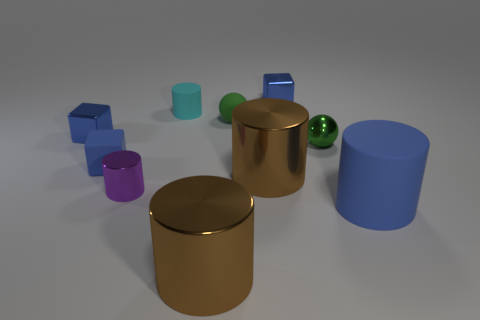Subtract all shiny blocks. How many blocks are left? 1 Subtract all blue cylinders. How many cylinders are left? 4 Subtract 1 balls. How many balls are left? 1 Subtract all cubes. How many objects are left? 7 Add 5 cyan rubber cylinders. How many cyan rubber cylinders are left? 6 Add 8 tiny green shiny spheres. How many tiny green shiny spheres exist? 9 Subtract 2 green balls. How many objects are left? 8 Subtract all cyan balls. Subtract all cyan cubes. How many balls are left? 2 Subtract all yellow cylinders. How many red spheres are left? 0 Subtract all big metallic objects. Subtract all small green balls. How many objects are left? 6 